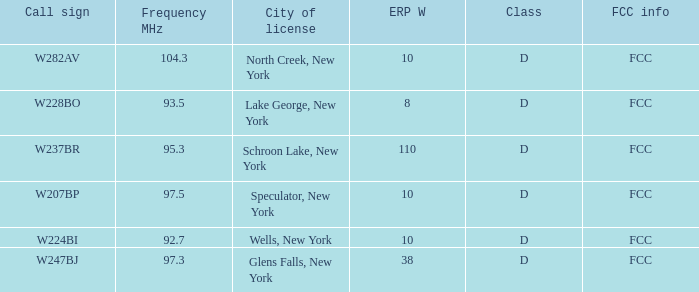Write the full table. {'header': ['Call sign', 'Frequency MHz', 'City of license', 'ERP W', 'Class', 'FCC info'], 'rows': [['W282AV', '104.3', 'North Creek, New York', '10', 'D', 'FCC'], ['W228BO', '93.5', 'Lake George, New York', '8', 'D', 'FCC'], ['W237BR', '95.3', 'Schroon Lake, New York', '110', 'D', 'FCC'], ['W207BP', '97.5', 'Speculator, New York', '10', 'D', 'FCC'], ['W224BI', '92.7', 'Wells, New York', '10', 'D', 'FCC'], ['W247BJ', '97.3', 'Glens Falls, New York', '38', 'D', 'FCC']]} Name the FCC info for frequency Mhz less than 97.3 and call sign of w237br FCC. 